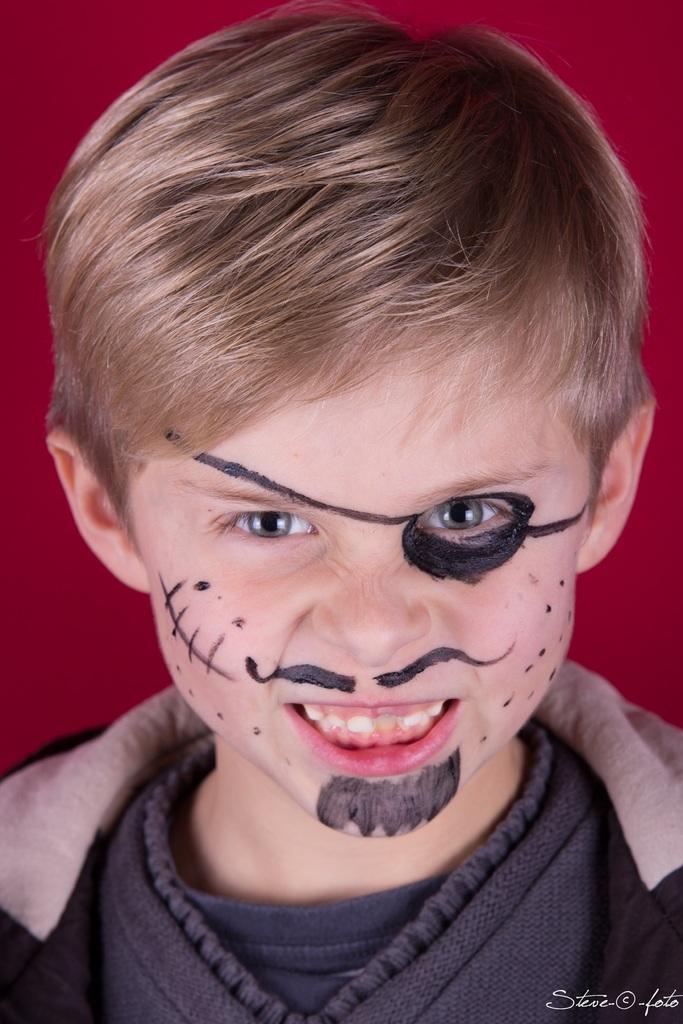Could you give a brief overview of what you see in this image? In this picture we can see a boy with a painting on his face and smiling and in the background it is red. 